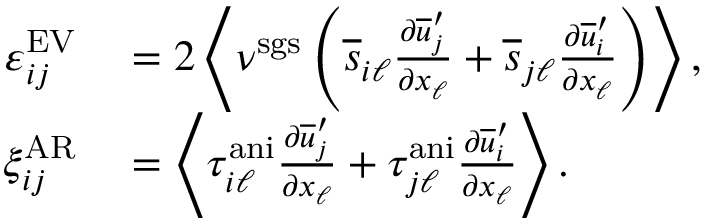<formula> <loc_0><loc_0><loc_500><loc_500>\begin{array} { r l } { \varepsilon _ { i j } ^ { E V } } & = 2 \left < \nu ^ { s g s } \left ( \overline { s } _ { i \ell } \frac { \partial \overline { u } _ { j } ^ { \prime } } { \partial x _ { \ell } } + \overline { s } _ { j \ell } \frac { \partial \overline { u } _ { i } ^ { \prime } } { \partial x _ { \ell } } \right ) \right > , } \\ { \xi _ { i j } ^ { A R } } & = \left < \tau _ { i \ell } ^ { a n i } \frac { \partial \overline { u } _ { j } ^ { \prime } } { \partial x _ { \ell } } + \tau _ { j \ell } ^ { a n i } \frac { \partial \overline { u } _ { i } ^ { \prime } } { \partial x _ { \ell } } \right > . } \end{array}</formula> 